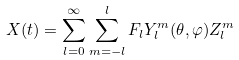Convert formula to latex. <formula><loc_0><loc_0><loc_500><loc_500>X ( t ) = \sum _ { l = 0 } ^ { \infty } \sum _ { m = - l } ^ { l } F _ { l } Y _ { l } ^ { m } ( \theta , \varphi ) Z _ { l } ^ { m }</formula> 